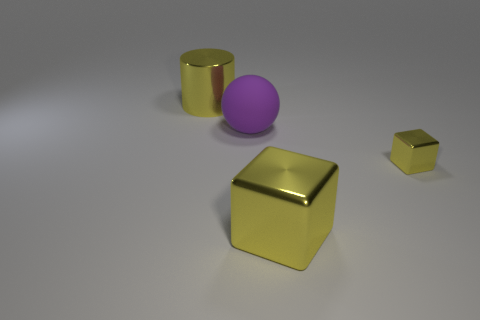Add 1 large objects. How many objects exist? 5 Subtract all cylinders. How many objects are left? 3 Subtract 0 red cylinders. How many objects are left? 4 Subtract 1 spheres. How many spheres are left? 0 Subtract all gray cubes. Subtract all red balls. How many cubes are left? 2 Subtract all big metallic objects. Subtract all cylinders. How many objects are left? 1 Add 3 big yellow cylinders. How many big yellow cylinders are left? 4 Add 4 large brown metallic cubes. How many large brown metallic cubes exist? 4 